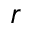Convert formula to latex. <formula><loc_0><loc_0><loc_500><loc_500>r</formula> 